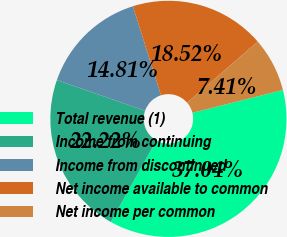Convert chart to OTSL. <chart><loc_0><loc_0><loc_500><loc_500><pie_chart><fcel>Total revenue (1)<fcel>Income from continuing<fcel>Income from discontinued<fcel>Net income available to common<fcel>Net income per common<nl><fcel>37.04%<fcel>22.22%<fcel>14.81%<fcel>18.52%<fcel>7.41%<nl></chart> 